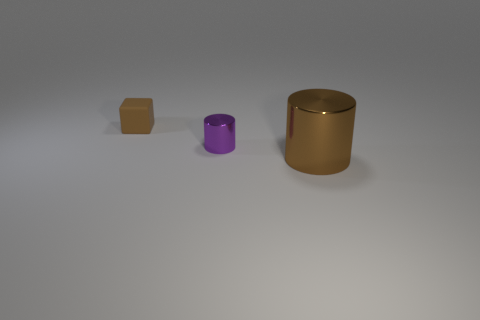What is the size of the object on the right side of the small object that is on the right side of the brown thing that is to the left of the large thing?
Ensure brevity in your answer.  Large. Is the shape of the brown metal thing the same as the small object on the right side of the small rubber cube?
Offer a very short reply. Yes. What is the material of the brown cube?
Ensure brevity in your answer.  Rubber. What number of metal things are either small brown blocks or small green things?
Your response must be concise. 0. Are there fewer small rubber things that are in front of the small shiny cylinder than small purple metal objects that are to the left of the small rubber thing?
Your response must be concise. No. There is a tiny object that is to the right of the brown cube left of the purple cylinder; are there any small metal cylinders that are in front of it?
Offer a very short reply. No. There is a object that is the same color as the small matte cube; what is its material?
Ensure brevity in your answer.  Metal. Is the shape of the metal object behind the large shiny thing the same as the brown object in front of the rubber object?
Your response must be concise. Yes. There is another thing that is the same size as the matte object; what material is it?
Your response must be concise. Metal. Do the brown object behind the purple metal cylinder and the small thing that is on the right side of the tiny brown cube have the same material?
Your answer should be compact. No. 